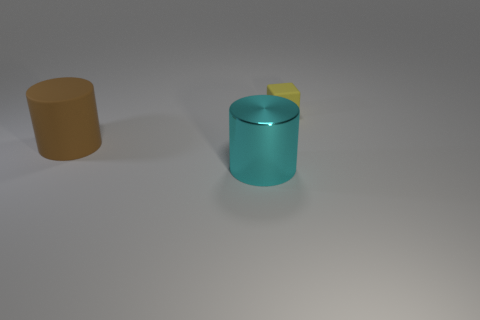Add 2 green metallic things. How many objects exist? 5 Subtract all cylinders. How many objects are left? 1 Subtract all tiny purple metal balls. Subtract all matte cubes. How many objects are left? 2 Add 2 cubes. How many cubes are left? 3 Add 2 blue rubber spheres. How many blue rubber spheres exist? 2 Subtract 0 green spheres. How many objects are left? 3 